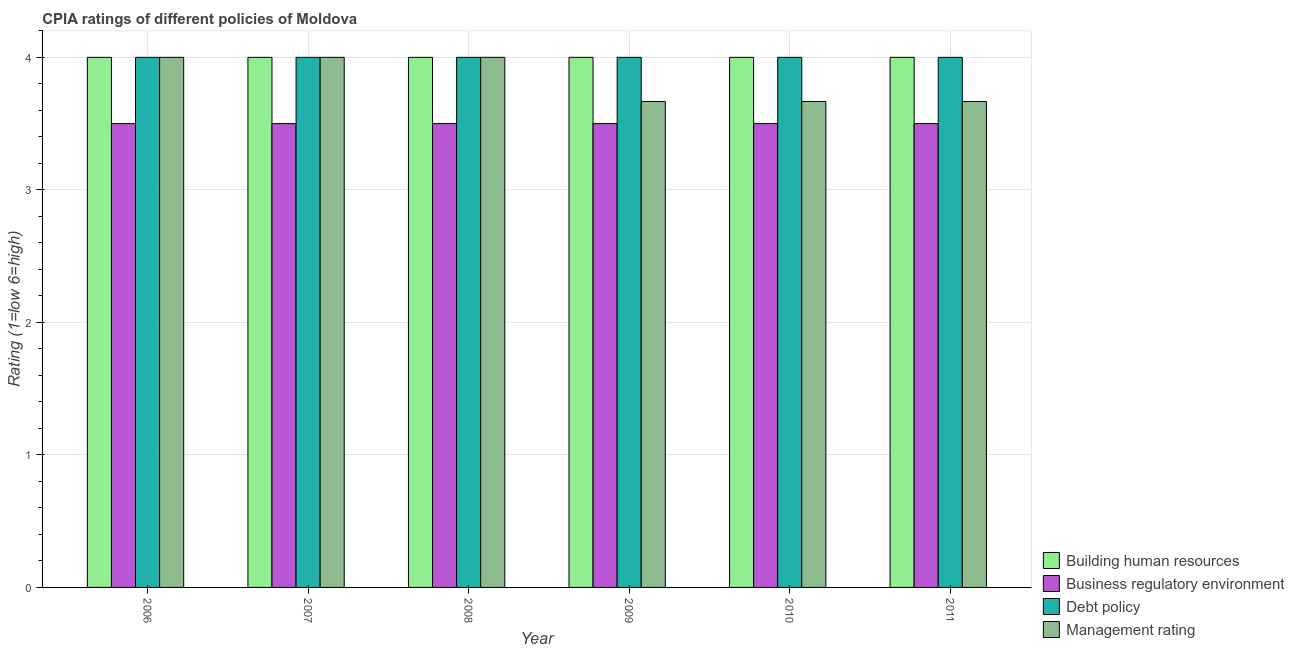How many different coloured bars are there?
Offer a terse response. 4. How many groups of bars are there?
Make the answer very short. 6. Are the number of bars on each tick of the X-axis equal?
Offer a terse response. Yes. How many bars are there on the 5th tick from the right?
Provide a succinct answer. 4. What is the cpia rating of building human resources in 2006?
Your response must be concise. 4. Across all years, what is the maximum cpia rating of business regulatory environment?
Your answer should be very brief. 3.5. In which year was the cpia rating of management maximum?
Provide a short and direct response. 2006. What is the total cpia rating of management in the graph?
Your answer should be very brief. 23. What is the difference between the cpia rating of debt policy in 2009 and the cpia rating of management in 2010?
Make the answer very short. 0. What is the average cpia rating of debt policy per year?
Provide a succinct answer. 4. In the year 2007, what is the difference between the cpia rating of building human resources and cpia rating of management?
Make the answer very short. 0. What is the ratio of the cpia rating of building human resources in 2007 to that in 2010?
Your answer should be compact. 1. Is the difference between the cpia rating of debt policy in 2007 and 2009 greater than the difference between the cpia rating of building human resources in 2007 and 2009?
Your answer should be very brief. No. What is the difference between the highest and the second highest cpia rating of business regulatory environment?
Your answer should be very brief. 0. In how many years, is the cpia rating of business regulatory environment greater than the average cpia rating of business regulatory environment taken over all years?
Ensure brevity in your answer.  0. What does the 4th bar from the left in 2009 represents?
Give a very brief answer. Management rating. What does the 1st bar from the right in 2008 represents?
Your response must be concise. Management rating. How many bars are there?
Make the answer very short. 24. Are all the bars in the graph horizontal?
Your answer should be very brief. No. Does the graph contain grids?
Provide a short and direct response. Yes. What is the title of the graph?
Offer a very short reply. CPIA ratings of different policies of Moldova. Does "Denmark" appear as one of the legend labels in the graph?
Your answer should be compact. No. What is the Rating (1=low 6=high) of Business regulatory environment in 2006?
Your response must be concise. 3.5. What is the Rating (1=low 6=high) of Management rating in 2006?
Your answer should be compact. 4. What is the Rating (1=low 6=high) of Business regulatory environment in 2007?
Offer a very short reply. 3.5. What is the Rating (1=low 6=high) in Management rating in 2007?
Provide a succinct answer. 4. What is the Rating (1=low 6=high) of Building human resources in 2008?
Ensure brevity in your answer.  4. What is the Rating (1=low 6=high) of Debt policy in 2008?
Offer a very short reply. 4. What is the Rating (1=low 6=high) of Debt policy in 2009?
Provide a short and direct response. 4. What is the Rating (1=low 6=high) in Management rating in 2009?
Offer a terse response. 3.67. What is the Rating (1=low 6=high) of Business regulatory environment in 2010?
Offer a very short reply. 3.5. What is the Rating (1=low 6=high) in Debt policy in 2010?
Ensure brevity in your answer.  4. What is the Rating (1=low 6=high) in Management rating in 2010?
Your answer should be very brief. 3.67. What is the Rating (1=low 6=high) in Debt policy in 2011?
Provide a short and direct response. 4. What is the Rating (1=low 6=high) of Management rating in 2011?
Provide a succinct answer. 3.67. Across all years, what is the maximum Rating (1=low 6=high) of Debt policy?
Offer a terse response. 4. Across all years, what is the maximum Rating (1=low 6=high) in Management rating?
Offer a very short reply. 4. Across all years, what is the minimum Rating (1=low 6=high) of Building human resources?
Provide a succinct answer. 4. Across all years, what is the minimum Rating (1=low 6=high) of Business regulatory environment?
Make the answer very short. 3.5. Across all years, what is the minimum Rating (1=low 6=high) of Management rating?
Offer a very short reply. 3.67. What is the total Rating (1=low 6=high) of Business regulatory environment in the graph?
Keep it short and to the point. 21. What is the difference between the Rating (1=low 6=high) in Debt policy in 2006 and that in 2007?
Give a very brief answer. 0. What is the difference between the Rating (1=low 6=high) in Management rating in 2006 and that in 2007?
Offer a very short reply. 0. What is the difference between the Rating (1=low 6=high) of Business regulatory environment in 2006 and that in 2008?
Your answer should be compact. 0. What is the difference between the Rating (1=low 6=high) in Debt policy in 2006 and that in 2008?
Offer a very short reply. 0. What is the difference between the Rating (1=low 6=high) of Business regulatory environment in 2006 and that in 2009?
Ensure brevity in your answer.  0. What is the difference between the Rating (1=low 6=high) in Management rating in 2006 and that in 2009?
Offer a terse response. 0.33. What is the difference between the Rating (1=low 6=high) of Building human resources in 2006 and that in 2011?
Your answer should be very brief. 0. What is the difference between the Rating (1=low 6=high) in Debt policy in 2007 and that in 2008?
Your answer should be very brief. 0. What is the difference between the Rating (1=low 6=high) of Building human resources in 2007 and that in 2009?
Offer a terse response. 0. What is the difference between the Rating (1=low 6=high) in Debt policy in 2007 and that in 2009?
Give a very brief answer. 0. What is the difference between the Rating (1=low 6=high) in Business regulatory environment in 2007 and that in 2010?
Your answer should be compact. 0. What is the difference between the Rating (1=low 6=high) in Debt policy in 2007 and that in 2010?
Keep it short and to the point. 0. What is the difference between the Rating (1=low 6=high) of Building human resources in 2007 and that in 2011?
Your answer should be compact. 0. What is the difference between the Rating (1=low 6=high) of Debt policy in 2007 and that in 2011?
Your response must be concise. 0. What is the difference between the Rating (1=low 6=high) of Management rating in 2007 and that in 2011?
Make the answer very short. 0.33. What is the difference between the Rating (1=low 6=high) of Building human resources in 2008 and that in 2009?
Make the answer very short. 0. What is the difference between the Rating (1=low 6=high) in Business regulatory environment in 2008 and that in 2009?
Keep it short and to the point. 0. What is the difference between the Rating (1=low 6=high) in Management rating in 2008 and that in 2009?
Make the answer very short. 0.33. What is the difference between the Rating (1=low 6=high) in Management rating in 2008 and that in 2010?
Offer a terse response. 0.33. What is the difference between the Rating (1=low 6=high) in Building human resources in 2008 and that in 2011?
Your answer should be very brief. 0. What is the difference between the Rating (1=low 6=high) in Business regulatory environment in 2008 and that in 2011?
Your response must be concise. 0. What is the difference between the Rating (1=low 6=high) in Debt policy in 2008 and that in 2011?
Make the answer very short. 0. What is the difference between the Rating (1=low 6=high) of Building human resources in 2009 and that in 2010?
Keep it short and to the point. 0. What is the difference between the Rating (1=low 6=high) in Business regulatory environment in 2009 and that in 2010?
Offer a very short reply. 0. What is the difference between the Rating (1=low 6=high) in Debt policy in 2009 and that in 2010?
Keep it short and to the point. 0. What is the difference between the Rating (1=low 6=high) in Debt policy in 2009 and that in 2011?
Your answer should be very brief. 0. What is the difference between the Rating (1=low 6=high) of Management rating in 2009 and that in 2011?
Ensure brevity in your answer.  0. What is the difference between the Rating (1=low 6=high) of Building human resources in 2010 and that in 2011?
Your answer should be compact. 0. What is the difference between the Rating (1=low 6=high) in Debt policy in 2010 and that in 2011?
Ensure brevity in your answer.  0. What is the difference between the Rating (1=low 6=high) of Management rating in 2010 and that in 2011?
Your response must be concise. 0. What is the difference between the Rating (1=low 6=high) of Building human resources in 2006 and the Rating (1=low 6=high) of Management rating in 2007?
Offer a terse response. 0. What is the difference between the Rating (1=low 6=high) in Building human resources in 2006 and the Rating (1=low 6=high) in Debt policy in 2008?
Offer a very short reply. 0. What is the difference between the Rating (1=low 6=high) of Building human resources in 2006 and the Rating (1=low 6=high) of Management rating in 2008?
Make the answer very short. 0. What is the difference between the Rating (1=low 6=high) in Debt policy in 2006 and the Rating (1=low 6=high) in Management rating in 2008?
Ensure brevity in your answer.  0. What is the difference between the Rating (1=low 6=high) of Building human resources in 2006 and the Rating (1=low 6=high) of Business regulatory environment in 2009?
Your response must be concise. 0.5. What is the difference between the Rating (1=low 6=high) in Building human resources in 2006 and the Rating (1=low 6=high) in Debt policy in 2009?
Provide a short and direct response. 0. What is the difference between the Rating (1=low 6=high) in Business regulatory environment in 2006 and the Rating (1=low 6=high) in Debt policy in 2009?
Make the answer very short. -0.5. What is the difference between the Rating (1=low 6=high) in Building human resources in 2006 and the Rating (1=low 6=high) in Management rating in 2010?
Keep it short and to the point. 0.33. What is the difference between the Rating (1=low 6=high) of Business regulatory environment in 2006 and the Rating (1=low 6=high) of Management rating in 2010?
Ensure brevity in your answer.  -0.17. What is the difference between the Rating (1=low 6=high) in Debt policy in 2006 and the Rating (1=low 6=high) in Management rating in 2010?
Your answer should be compact. 0.33. What is the difference between the Rating (1=low 6=high) of Building human resources in 2006 and the Rating (1=low 6=high) of Business regulatory environment in 2011?
Offer a very short reply. 0.5. What is the difference between the Rating (1=low 6=high) in Business regulatory environment in 2006 and the Rating (1=low 6=high) in Debt policy in 2011?
Give a very brief answer. -0.5. What is the difference between the Rating (1=low 6=high) of Debt policy in 2006 and the Rating (1=low 6=high) of Management rating in 2011?
Keep it short and to the point. 0.33. What is the difference between the Rating (1=low 6=high) of Building human resources in 2007 and the Rating (1=low 6=high) of Business regulatory environment in 2008?
Keep it short and to the point. 0.5. What is the difference between the Rating (1=low 6=high) in Building human resources in 2007 and the Rating (1=low 6=high) in Debt policy in 2008?
Your answer should be compact. 0. What is the difference between the Rating (1=low 6=high) in Building human resources in 2007 and the Rating (1=low 6=high) in Management rating in 2008?
Offer a terse response. 0. What is the difference between the Rating (1=low 6=high) in Business regulatory environment in 2007 and the Rating (1=low 6=high) in Debt policy in 2008?
Give a very brief answer. -0.5. What is the difference between the Rating (1=low 6=high) of Business regulatory environment in 2007 and the Rating (1=low 6=high) of Management rating in 2008?
Ensure brevity in your answer.  -0.5. What is the difference between the Rating (1=low 6=high) in Building human resources in 2007 and the Rating (1=low 6=high) in Management rating in 2009?
Keep it short and to the point. 0.33. What is the difference between the Rating (1=low 6=high) in Business regulatory environment in 2007 and the Rating (1=low 6=high) in Debt policy in 2009?
Your answer should be very brief. -0.5. What is the difference between the Rating (1=low 6=high) in Business regulatory environment in 2007 and the Rating (1=low 6=high) in Management rating in 2009?
Your answer should be compact. -0.17. What is the difference between the Rating (1=low 6=high) in Building human resources in 2007 and the Rating (1=low 6=high) in Business regulatory environment in 2010?
Provide a succinct answer. 0.5. What is the difference between the Rating (1=low 6=high) in Building human resources in 2007 and the Rating (1=low 6=high) in Debt policy in 2010?
Your answer should be very brief. 0. What is the difference between the Rating (1=low 6=high) in Building human resources in 2007 and the Rating (1=low 6=high) in Management rating in 2010?
Your response must be concise. 0.33. What is the difference between the Rating (1=low 6=high) in Business regulatory environment in 2007 and the Rating (1=low 6=high) in Debt policy in 2010?
Offer a terse response. -0.5. What is the difference between the Rating (1=low 6=high) in Business regulatory environment in 2007 and the Rating (1=low 6=high) in Management rating in 2010?
Make the answer very short. -0.17. What is the difference between the Rating (1=low 6=high) of Debt policy in 2007 and the Rating (1=low 6=high) of Management rating in 2010?
Offer a very short reply. 0.33. What is the difference between the Rating (1=low 6=high) in Building human resources in 2007 and the Rating (1=low 6=high) in Debt policy in 2011?
Provide a short and direct response. 0. What is the difference between the Rating (1=low 6=high) in Building human resources in 2007 and the Rating (1=low 6=high) in Management rating in 2011?
Offer a terse response. 0.33. What is the difference between the Rating (1=low 6=high) in Business regulatory environment in 2007 and the Rating (1=low 6=high) in Debt policy in 2011?
Give a very brief answer. -0.5. What is the difference between the Rating (1=low 6=high) in Building human resources in 2008 and the Rating (1=low 6=high) in Debt policy in 2009?
Offer a very short reply. 0. What is the difference between the Rating (1=low 6=high) in Business regulatory environment in 2008 and the Rating (1=low 6=high) in Management rating in 2009?
Offer a very short reply. -0.17. What is the difference between the Rating (1=low 6=high) in Building human resources in 2008 and the Rating (1=low 6=high) in Business regulatory environment in 2010?
Provide a short and direct response. 0.5. What is the difference between the Rating (1=low 6=high) in Building human resources in 2008 and the Rating (1=low 6=high) in Management rating in 2010?
Provide a short and direct response. 0.33. What is the difference between the Rating (1=low 6=high) of Business regulatory environment in 2008 and the Rating (1=low 6=high) of Debt policy in 2010?
Offer a very short reply. -0.5. What is the difference between the Rating (1=low 6=high) of Business regulatory environment in 2008 and the Rating (1=low 6=high) of Management rating in 2010?
Your answer should be compact. -0.17. What is the difference between the Rating (1=low 6=high) of Debt policy in 2008 and the Rating (1=low 6=high) of Management rating in 2010?
Keep it short and to the point. 0.33. What is the difference between the Rating (1=low 6=high) of Business regulatory environment in 2008 and the Rating (1=low 6=high) of Management rating in 2011?
Your answer should be compact. -0.17. What is the difference between the Rating (1=low 6=high) of Building human resources in 2009 and the Rating (1=low 6=high) of Debt policy in 2010?
Your answer should be very brief. 0. What is the difference between the Rating (1=low 6=high) in Building human resources in 2009 and the Rating (1=low 6=high) in Management rating in 2010?
Offer a very short reply. 0.33. What is the difference between the Rating (1=low 6=high) of Business regulatory environment in 2009 and the Rating (1=low 6=high) of Debt policy in 2010?
Provide a succinct answer. -0.5. What is the difference between the Rating (1=low 6=high) in Building human resources in 2009 and the Rating (1=low 6=high) in Debt policy in 2011?
Provide a short and direct response. 0. What is the difference between the Rating (1=low 6=high) of Business regulatory environment in 2009 and the Rating (1=low 6=high) of Management rating in 2011?
Make the answer very short. -0.17. What is the difference between the Rating (1=low 6=high) of Building human resources in 2010 and the Rating (1=low 6=high) of Business regulatory environment in 2011?
Your response must be concise. 0.5. What is the difference between the Rating (1=low 6=high) in Building human resources in 2010 and the Rating (1=low 6=high) in Management rating in 2011?
Keep it short and to the point. 0.33. What is the difference between the Rating (1=low 6=high) of Business regulatory environment in 2010 and the Rating (1=low 6=high) of Management rating in 2011?
Your answer should be compact. -0.17. What is the difference between the Rating (1=low 6=high) in Debt policy in 2010 and the Rating (1=low 6=high) in Management rating in 2011?
Keep it short and to the point. 0.33. What is the average Rating (1=low 6=high) of Business regulatory environment per year?
Give a very brief answer. 3.5. What is the average Rating (1=low 6=high) in Management rating per year?
Ensure brevity in your answer.  3.83. In the year 2006, what is the difference between the Rating (1=low 6=high) of Building human resources and Rating (1=low 6=high) of Debt policy?
Keep it short and to the point. 0. In the year 2006, what is the difference between the Rating (1=low 6=high) of Business regulatory environment and Rating (1=low 6=high) of Debt policy?
Give a very brief answer. -0.5. In the year 2006, what is the difference between the Rating (1=low 6=high) of Business regulatory environment and Rating (1=low 6=high) of Management rating?
Provide a succinct answer. -0.5. In the year 2007, what is the difference between the Rating (1=low 6=high) of Building human resources and Rating (1=low 6=high) of Management rating?
Ensure brevity in your answer.  0. In the year 2007, what is the difference between the Rating (1=low 6=high) in Business regulatory environment and Rating (1=low 6=high) in Debt policy?
Your response must be concise. -0.5. In the year 2008, what is the difference between the Rating (1=low 6=high) in Building human resources and Rating (1=low 6=high) in Debt policy?
Provide a succinct answer. 0. In the year 2008, what is the difference between the Rating (1=low 6=high) in Building human resources and Rating (1=low 6=high) in Management rating?
Offer a terse response. 0. In the year 2009, what is the difference between the Rating (1=low 6=high) of Building human resources and Rating (1=low 6=high) of Business regulatory environment?
Offer a very short reply. 0.5. In the year 2009, what is the difference between the Rating (1=low 6=high) of Building human resources and Rating (1=low 6=high) of Debt policy?
Your answer should be compact. 0. In the year 2009, what is the difference between the Rating (1=low 6=high) of Building human resources and Rating (1=low 6=high) of Management rating?
Ensure brevity in your answer.  0.33. In the year 2009, what is the difference between the Rating (1=low 6=high) in Business regulatory environment and Rating (1=low 6=high) in Management rating?
Ensure brevity in your answer.  -0.17. In the year 2010, what is the difference between the Rating (1=low 6=high) in Building human resources and Rating (1=low 6=high) in Business regulatory environment?
Your answer should be very brief. 0.5. In the year 2010, what is the difference between the Rating (1=low 6=high) in Business regulatory environment and Rating (1=low 6=high) in Management rating?
Offer a terse response. -0.17. In the year 2010, what is the difference between the Rating (1=low 6=high) of Debt policy and Rating (1=low 6=high) of Management rating?
Your answer should be very brief. 0.33. In the year 2011, what is the difference between the Rating (1=low 6=high) of Building human resources and Rating (1=low 6=high) of Business regulatory environment?
Your answer should be very brief. 0.5. In the year 2011, what is the difference between the Rating (1=low 6=high) in Business regulatory environment and Rating (1=low 6=high) in Debt policy?
Provide a succinct answer. -0.5. In the year 2011, what is the difference between the Rating (1=low 6=high) in Business regulatory environment and Rating (1=low 6=high) in Management rating?
Offer a very short reply. -0.17. What is the ratio of the Rating (1=low 6=high) of Management rating in 2006 to that in 2007?
Make the answer very short. 1. What is the ratio of the Rating (1=low 6=high) in Building human resources in 2006 to that in 2008?
Give a very brief answer. 1. What is the ratio of the Rating (1=low 6=high) in Business regulatory environment in 2006 to that in 2008?
Your answer should be very brief. 1. What is the ratio of the Rating (1=low 6=high) in Building human resources in 2006 to that in 2009?
Make the answer very short. 1. What is the ratio of the Rating (1=low 6=high) of Business regulatory environment in 2006 to that in 2009?
Ensure brevity in your answer.  1. What is the ratio of the Rating (1=low 6=high) in Debt policy in 2006 to that in 2009?
Ensure brevity in your answer.  1. What is the ratio of the Rating (1=low 6=high) in Building human resources in 2006 to that in 2010?
Provide a succinct answer. 1. What is the ratio of the Rating (1=low 6=high) of Business regulatory environment in 2006 to that in 2010?
Give a very brief answer. 1. What is the ratio of the Rating (1=low 6=high) of Management rating in 2006 to that in 2011?
Give a very brief answer. 1.09. What is the ratio of the Rating (1=low 6=high) in Business regulatory environment in 2007 to that in 2008?
Your response must be concise. 1. What is the ratio of the Rating (1=low 6=high) of Debt policy in 2007 to that in 2008?
Make the answer very short. 1. What is the ratio of the Rating (1=low 6=high) of Debt policy in 2007 to that in 2009?
Your answer should be compact. 1. What is the ratio of the Rating (1=low 6=high) in Management rating in 2007 to that in 2009?
Your response must be concise. 1.09. What is the ratio of the Rating (1=low 6=high) in Debt policy in 2007 to that in 2011?
Ensure brevity in your answer.  1. What is the ratio of the Rating (1=low 6=high) in Management rating in 2007 to that in 2011?
Provide a succinct answer. 1.09. What is the ratio of the Rating (1=low 6=high) of Debt policy in 2008 to that in 2009?
Provide a short and direct response. 1. What is the ratio of the Rating (1=low 6=high) in Building human resources in 2008 to that in 2010?
Keep it short and to the point. 1. What is the ratio of the Rating (1=low 6=high) of Business regulatory environment in 2008 to that in 2010?
Ensure brevity in your answer.  1. What is the ratio of the Rating (1=low 6=high) of Debt policy in 2008 to that in 2010?
Provide a short and direct response. 1. What is the ratio of the Rating (1=low 6=high) of Debt policy in 2008 to that in 2011?
Ensure brevity in your answer.  1. What is the ratio of the Rating (1=low 6=high) in Management rating in 2008 to that in 2011?
Offer a very short reply. 1.09. What is the ratio of the Rating (1=low 6=high) of Business regulatory environment in 2009 to that in 2010?
Keep it short and to the point. 1. What is the ratio of the Rating (1=low 6=high) of Debt policy in 2009 to that in 2010?
Keep it short and to the point. 1. What is the ratio of the Rating (1=low 6=high) in Management rating in 2009 to that in 2010?
Offer a very short reply. 1. What is the ratio of the Rating (1=low 6=high) in Building human resources in 2010 to that in 2011?
Offer a very short reply. 1. What is the ratio of the Rating (1=low 6=high) of Business regulatory environment in 2010 to that in 2011?
Offer a very short reply. 1. What is the ratio of the Rating (1=low 6=high) in Debt policy in 2010 to that in 2011?
Your answer should be compact. 1. What is the ratio of the Rating (1=low 6=high) in Management rating in 2010 to that in 2011?
Your response must be concise. 1. What is the difference between the highest and the second highest Rating (1=low 6=high) of Debt policy?
Offer a terse response. 0. What is the difference between the highest and the lowest Rating (1=low 6=high) in Building human resources?
Ensure brevity in your answer.  0. What is the difference between the highest and the lowest Rating (1=low 6=high) in Business regulatory environment?
Provide a succinct answer. 0. What is the difference between the highest and the lowest Rating (1=low 6=high) in Management rating?
Offer a very short reply. 0.33. 